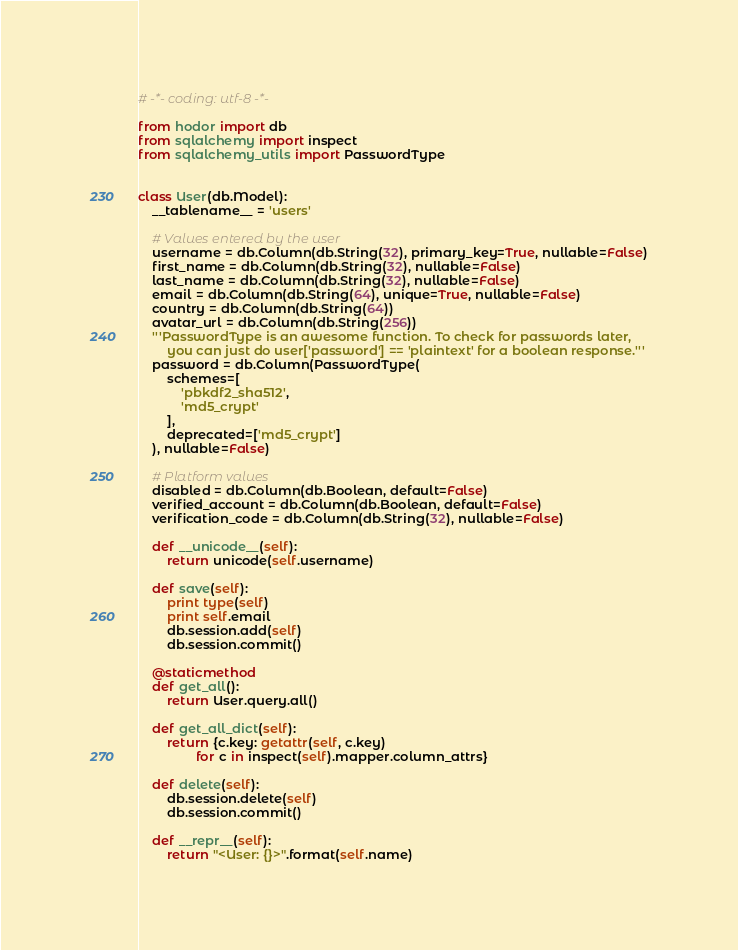Convert code to text. <code><loc_0><loc_0><loc_500><loc_500><_Python_># -*- coding: utf-8 -*-

from hodor import db
from sqlalchemy import inspect
from sqlalchemy_utils import PasswordType


class User(db.Model):
    __tablename__ = 'users'

    # Values entered by the user
    username = db.Column(db.String(32), primary_key=True, nullable=False)
    first_name = db.Column(db.String(32), nullable=False)
    last_name = db.Column(db.String(32), nullable=False)
    email = db.Column(db.String(64), unique=True, nullable=False)
    country = db.Column(db.String(64))
    avatar_url = db.Column(db.String(256))
    '''PasswordType is an awesome function. To check for passwords later,
        you can just do user['password'] == 'plaintext' for a boolean response.'''
    password = db.Column(PasswordType(
        schemes=[
            'pbkdf2_sha512',
            'md5_crypt'
        ],
        deprecated=['md5_crypt']
    ), nullable=False)

    # Platform values
    disabled = db.Column(db.Boolean, default=False)
    verified_account = db.Column(db.Boolean, default=False)
    verification_code = db.Column(db.String(32), nullable=False)

    def __unicode__(self):
        return unicode(self.username)

    def save(self):
        print type(self)
        print self.email
        db.session.add(self)
        db.session.commit()

    @staticmethod
    def get_all():
        return User.query.all()

    def get_all_dict(self):
        return {c.key: getattr(self, c.key)
                for c in inspect(self).mapper.column_attrs}

    def delete(self):
        db.session.delete(self)
        db.session.commit()

    def __repr__(self):
        return "<User: {}>".format(self.name)
</code> 